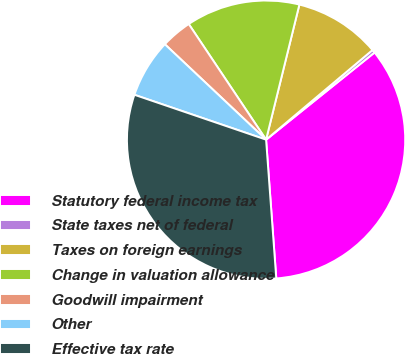Convert chart to OTSL. <chart><loc_0><loc_0><loc_500><loc_500><pie_chart><fcel>Statutory federal income tax<fcel>State taxes net of federal<fcel>Taxes on foreign earnings<fcel>Change in valuation allowance<fcel>Goodwill impairment<fcel>Other<fcel>Effective tax rate<nl><fcel>34.61%<fcel>0.37%<fcel>10.01%<fcel>13.23%<fcel>3.59%<fcel>6.8%<fcel>31.4%<nl></chart> 